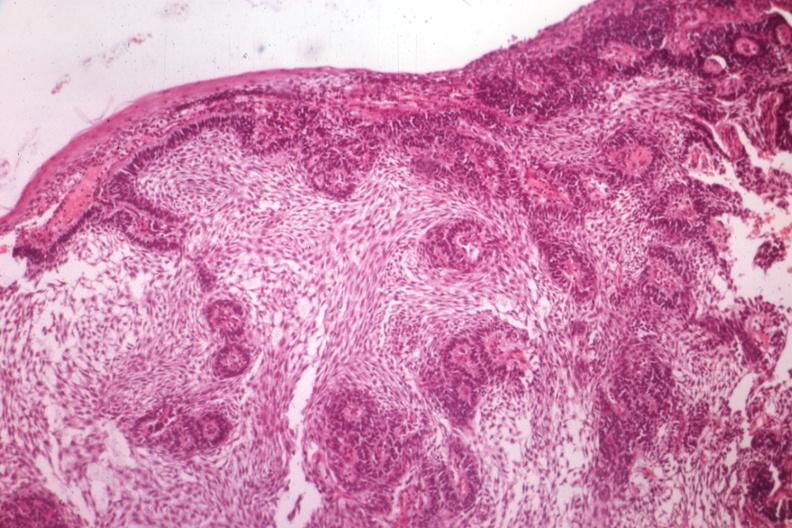what is present?
Answer the question using a single word or phrase. Ameloblastoma 